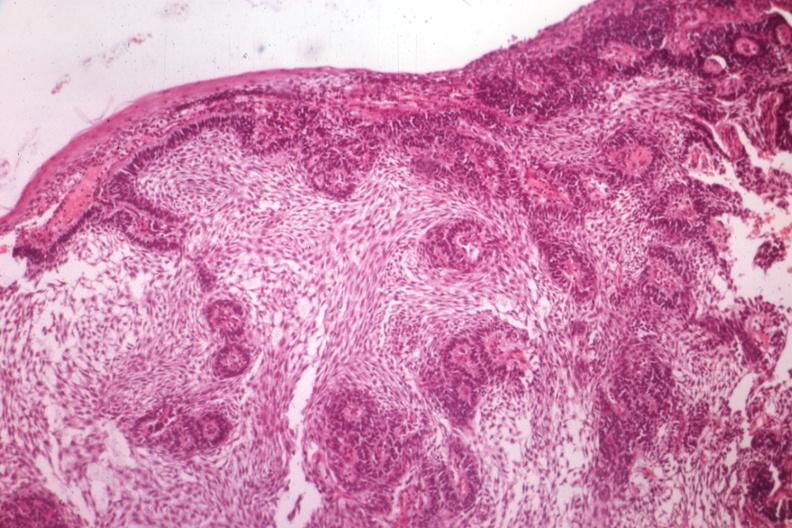what is present?
Answer the question using a single word or phrase. Ameloblastoma 